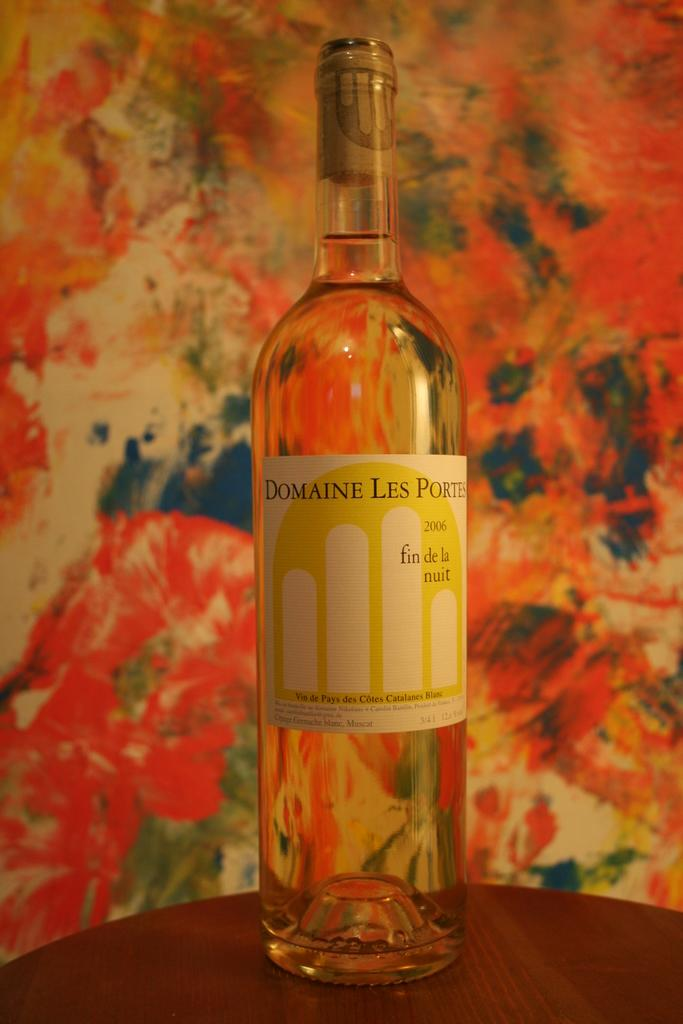What is the main object in the image? There is a wine bottle in the image. Where is the wine bottle located? The wine bottle is placed on a table. What can be seen in the background of the image? There is a wall painted in the background of the image. How does the wine bottle react to the rainstorm in the image? There is no rainstorm present in the image, so the wine bottle does not react to it. 